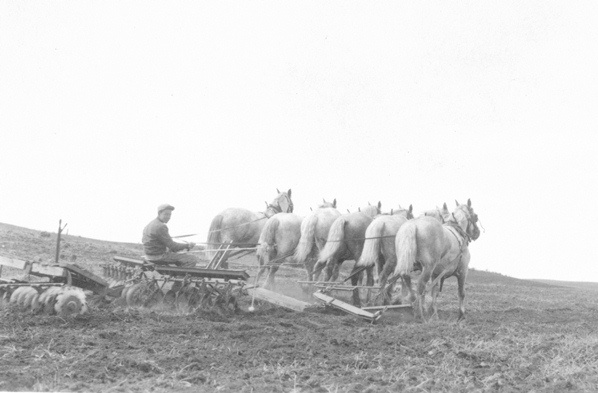Describe the objects in this image and their specific colors. I can see horse in darkgray, lightgray, gray, and white tones, horse in darkgray, lightgray, gray, and white tones, horse in lightgray, darkgray, gray, and white tones, horse in lightgray, darkgray, gray, and white tones, and horse in darkgray, lightgray, gray, and white tones in this image. 